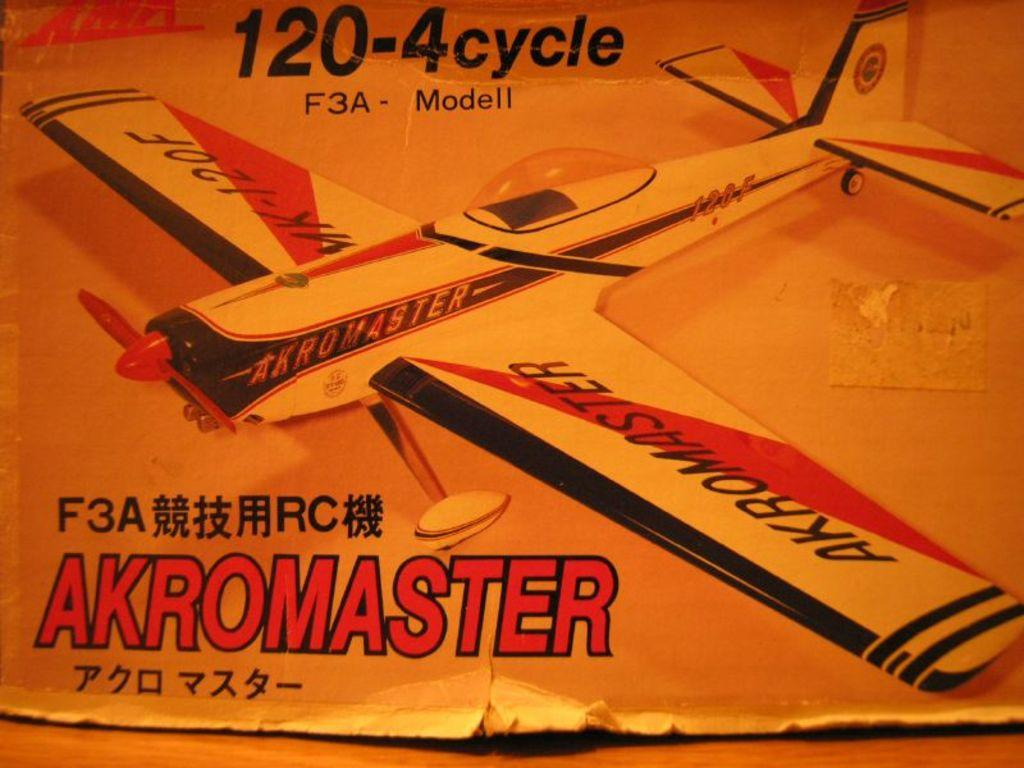<image>
Write a terse but informative summary of the picture. Orange piece of paper with a plane titled Akromaster. 